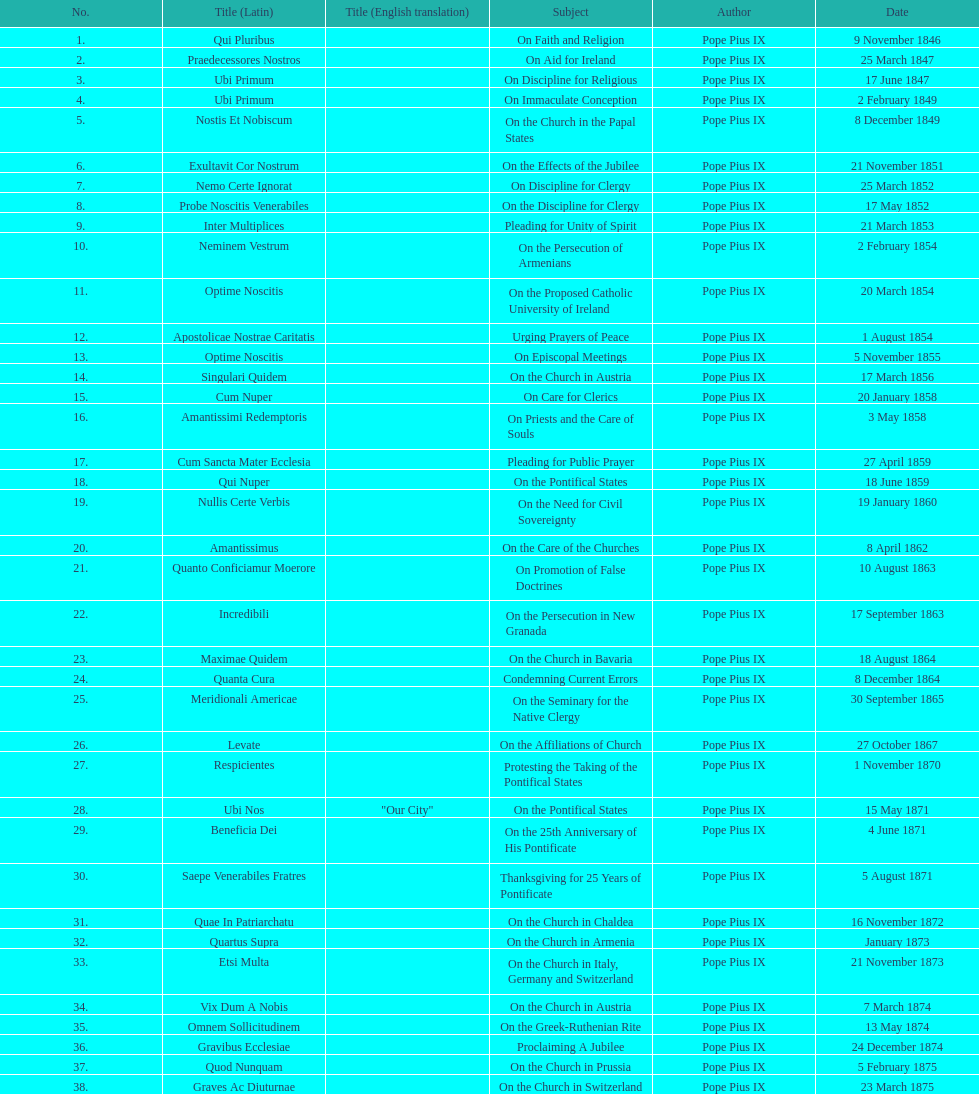How many subjects are there? 38. 